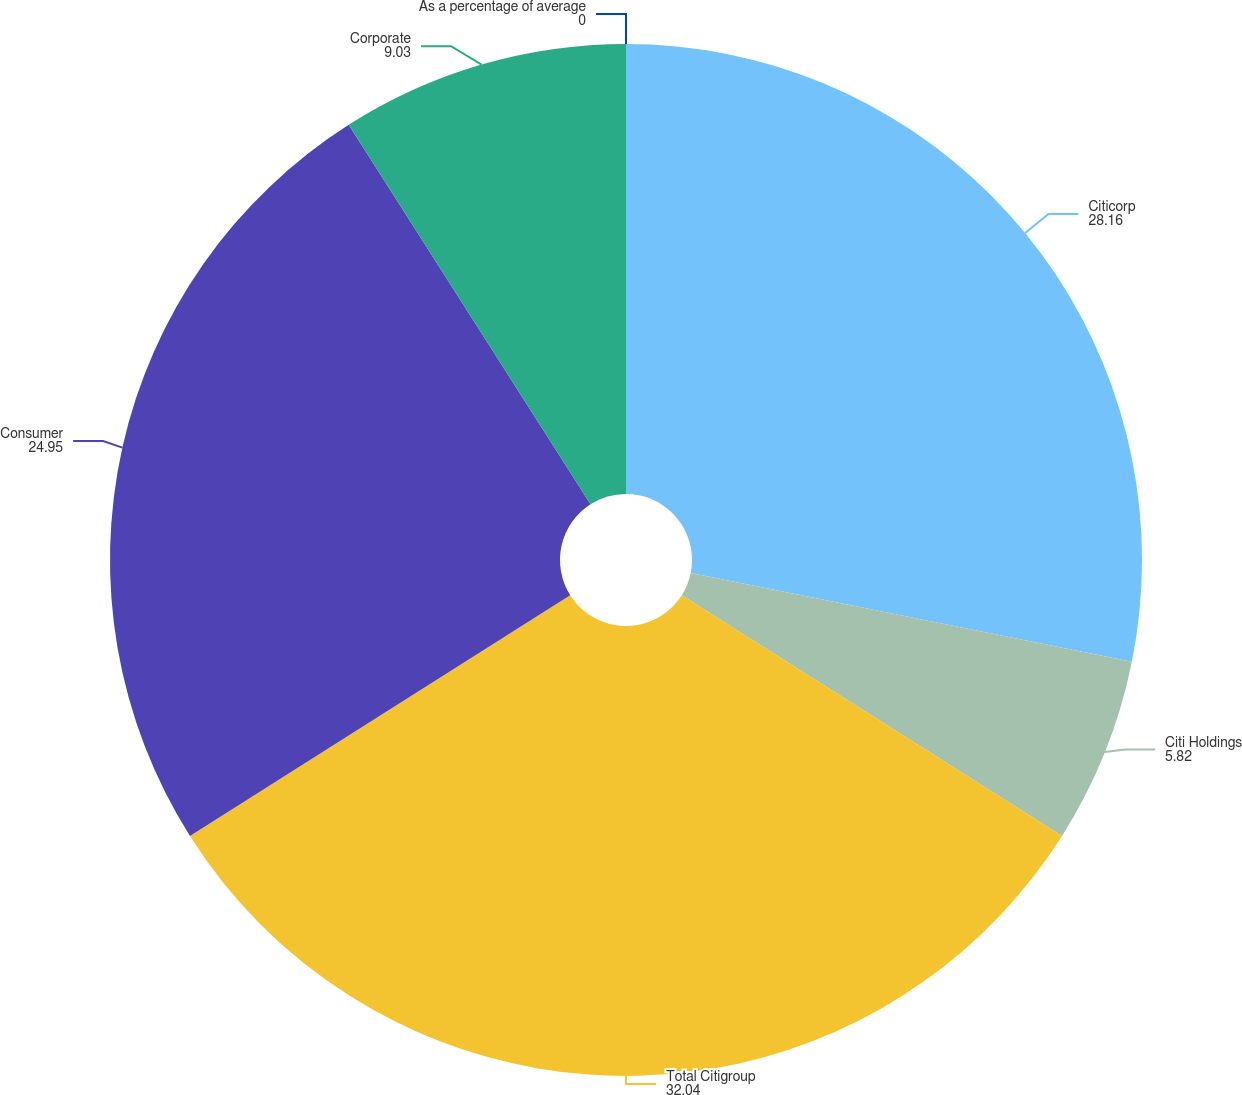<chart> <loc_0><loc_0><loc_500><loc_500><pie_chart><fcel>As a percentage of average<fcel>Citicorp<fcel>Citi Holdings<fcel>Total Citigroup<fcel>Consumer<fcel>Corporate<nl><fcel>0.0%<fcel>28.16%<fcel>5.82%<fcel>32.04%<fcel>24.95%<fcel>9.03%<nl></chart> 